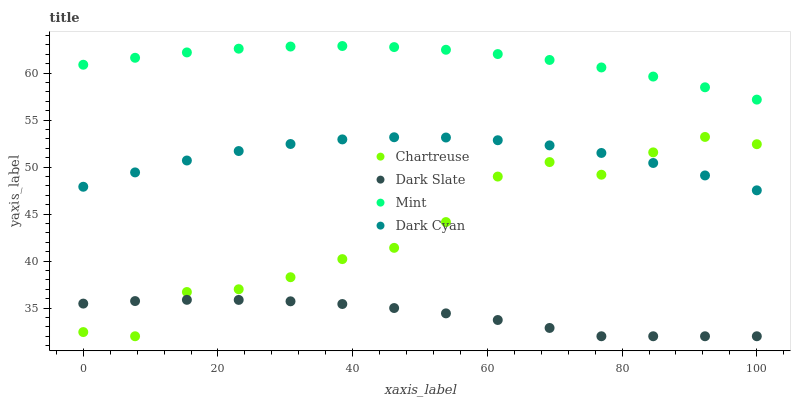Does Dark Slate have the minimum area under the curve?
Answer yes or no. Yes. Does Mint have the maximum area under the curve?
Answer yes or no. Yes. Does Chartreuse have the minimum area under the curve?
Answer yes or no. No. Does Chartreuse have the maximum area under the curve?
Answer yes or no. No. Is Dark Slate the smoothest?
Answer yes or no. Yes. Is Chartreuse the roughest?
Answer yes or no. Yes. Is Chartreuse the smoothest?
Answer yes or no. No. Is Dark Slate the roughest?
Answer yes or no. No. Does Dark Slate have the lowest value?
Answer yes or no. Yes. Does Mint have the lowest value?
Answer yes or no. No. Does Mint have the highest value?
Answer yes or no. Yes. Does Chartreuse have the highest value?
Answer yes or no. No. Is Dark Slate less than Mint?
Answer yes or no. Yes. Is Dark Cyan greater than Dark Slate?
Answer yes or no. Yes. Does Dark Slate intersect Chartreuse?
Answer yes or no. Yes. Is Dark Slate less than Chartreuse?
Answer yes or no. No. Is Dark Slate greater than Chartreuse?
Answer yes or no. No. Does Dark Slate intersect Mint?
Answer yes or no. No. 